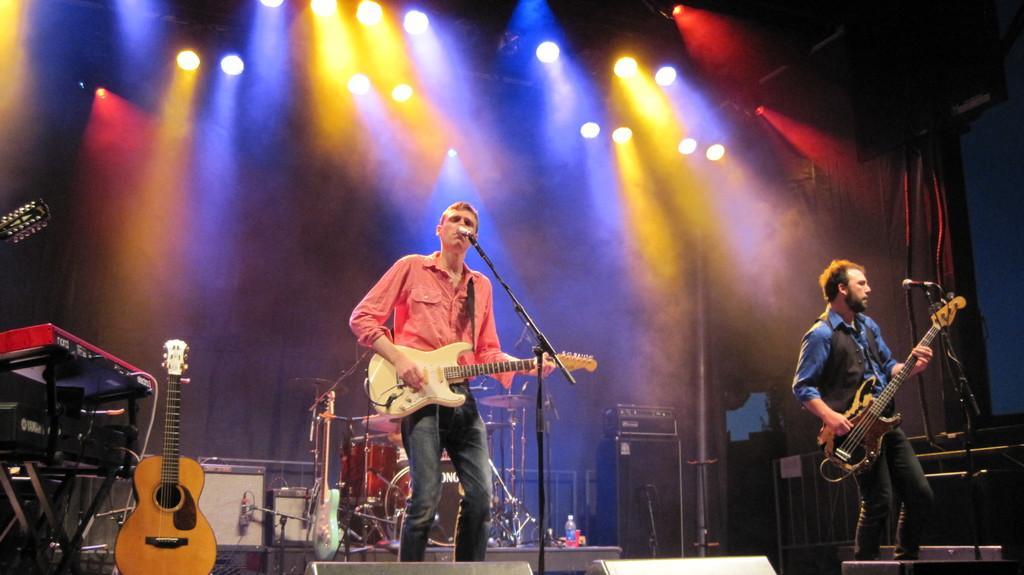Can you describe this image briefly? As we can see in the image, there are two people standing on stage, holding guitar in their hands and singing a song on mike. On the left side there is another guitar. On the top there are lights and behind the person there are few drums. 